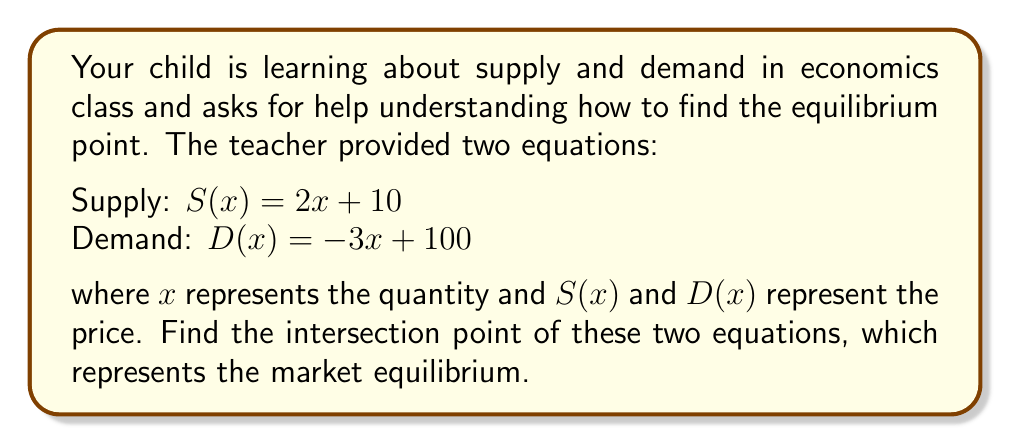Could you help me with this problem? Let's approach this step-by-step:

1) The intersection point occurs where supply equals demand. So, we set the equations equal to each other:

   $S(x) = D(x)$
   $2x + 10 = -3x + 100$

2) Now, we solve this equation for x:

   $2x + 10 = -3x + 100$
   $2x + 3x = 100 - 10$
   $5x = 90$

3) Divide both sides by 5:

   $x = 18$

4) This gives us the equilibrium quantity. To find the equilibrium price, we can substitute this x-value into either the supply or demand equation. Let's use the supply equation:

   $S(18) = 2(18) + 10 = 36 + 10 = 46$

5) Therefore, the intersection point (equilibrium point) is (18, 46).

This means that at a price of $46, both suppliers and consumers agree on a quantity of 18 units.
Answer: (18, 46) 